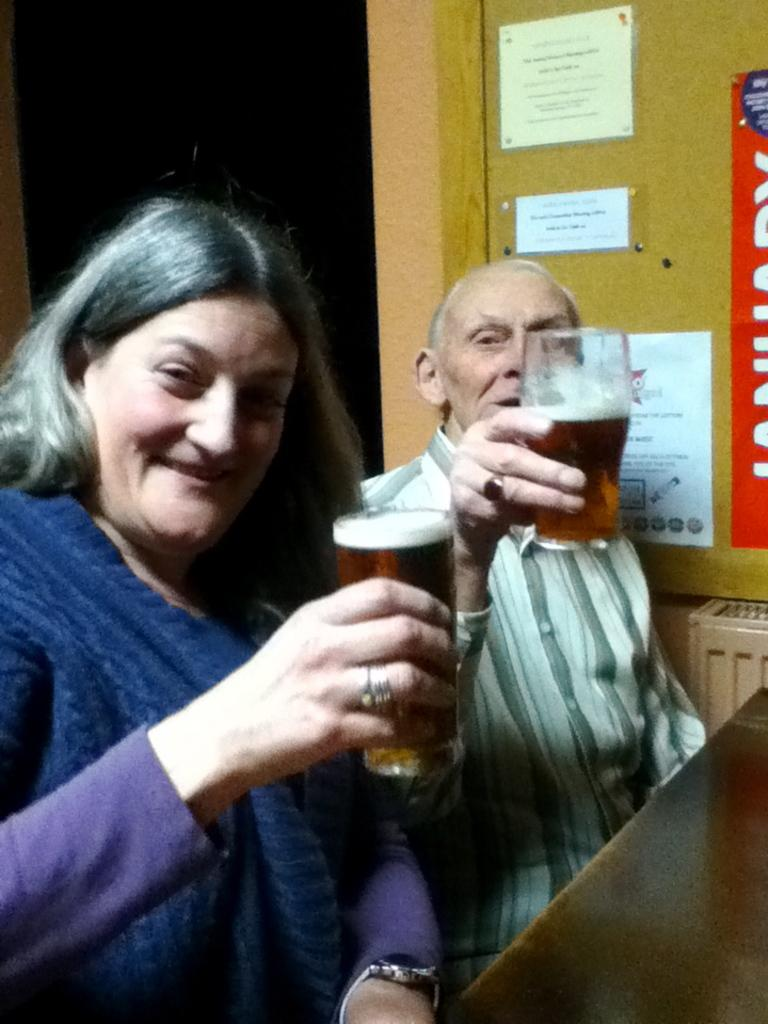What is the main object in the image? There is a table in the image. What is the color of the table? The table is black. What are the people at the table doing? The people are sitting at the table and holding wine glasses. What can be seen in the background of the image? There is a yellow color wall in the background of the image. What type of bait is being used to catch fish in the image? There is no mention of fishing or bait in the image; it features a table with people holding wine glasses. Can you tell me how the scarecrow is positioned in the image? There is no scarecrow present in the image. 